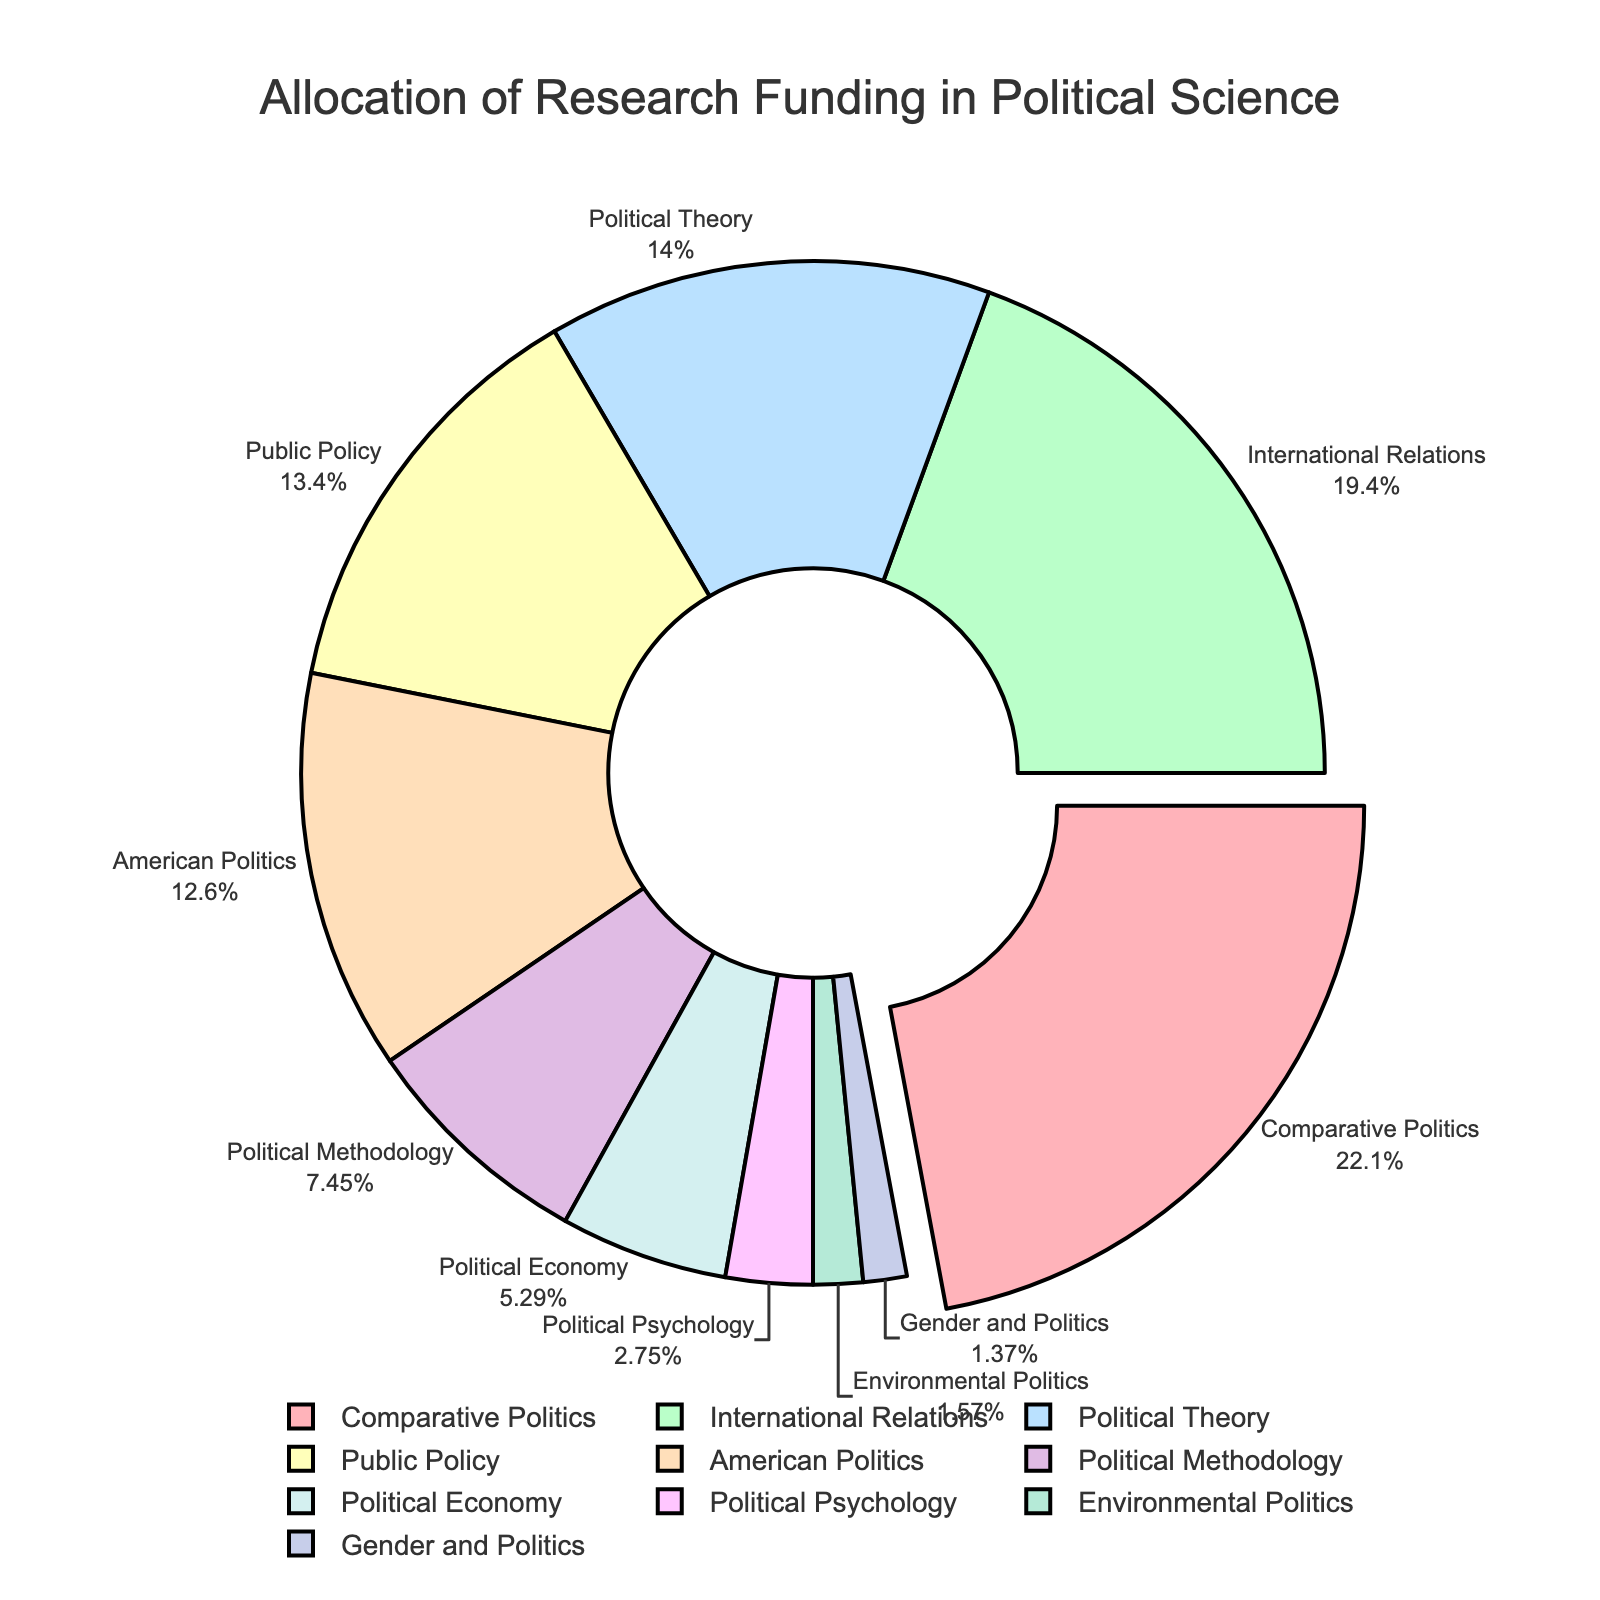Which sub-field receives the highest percentage of research funding? The sub-field with the largest portion of the pie chart, which is also visually pulled out from the rest of the segments, represents the highest percentage.
Answer: Comparative Politics What percentage of funding goes to International Relations and Political Theory combined? The figures for International Relations and Political Theory are 19.8% and 14.3%, respectively. Adding these percentages together results in 19.8% + 14.3% = 34.1%.
Answer: 34.1% Which sub-field gets the least amount of funding? The smallest segment in the pie chart, visually determined, represents the sub-field with the least funding.
Answer: Gender and Politics How much more funding does Comparative Politics receive compared to Political Methodology? The percentage of funding for Comparative Politics is 22.5%, and for Political Methodology, it is 7.6%. The difference can be calculated as 22.5% - 7.6% = 14.9%.
Answer: 14.9% What is the total funding percentage allocated to sub-fields with more than 10% funding each? The sub-fields with more than 10% funding each are Comparative Politics (22.5%), International Relations (19.8%), Political Theory (14.3%), Public Policy (13.7%), and American Politics (12.9%). Summing these percentages: 22.5% + 19.8% + 14.3% + 13.7% + 12.9% = 83.2%.
Answer: 83.2% Is the funding for Political Economy greater than that for Political Psychology? By comparing the segments, Political Economy has a funding percentage of 5.4%, while Political Psychology has 2.8%. Since 5.4% is greater than 2.8%, Political Economy receives more funding.
Answer: Yes What is the difference in funding between the sub-field with the second-highest funding and the sub-field with the fourth-highest funding? The second-highest funding goes to International Relations with 19.8%, and the fourth-highest to Public Policy with 13.7%. The difference is 19.8% - 13.7% = 6.1%.
Answer: 6.1% Among American Politics and Political Methodology, which sub-field receives more funding and by how much? American Politics has a funding percentage of 12.9%, while Political Methodology has 7.6%. The difference is 12.9% - 7.6% = 5.3%.
Answer: American Politics, 5.3% What percentage of funding is allocated to sub-fields receiving less than 5% each? The sub-fields receiving less than 5% are Political Economy (5.4%), Political Psychology (2.8%), Environmental Politics (1.6%), and Gender and Politics (1.4%). Summing these percentages: 5.4% + 2.8% + 1.6% + 1.4% = 11.2%.
Answer: 11.2% Which sub-fields have funding percentages that fall between 5% and 15%? The sub-fields in this range are Political Methodology (7.6%), Political Economy (5.4%), and Political Theory (14.3%).
Answer: Political Methodology, Political Economy, Political Theory 